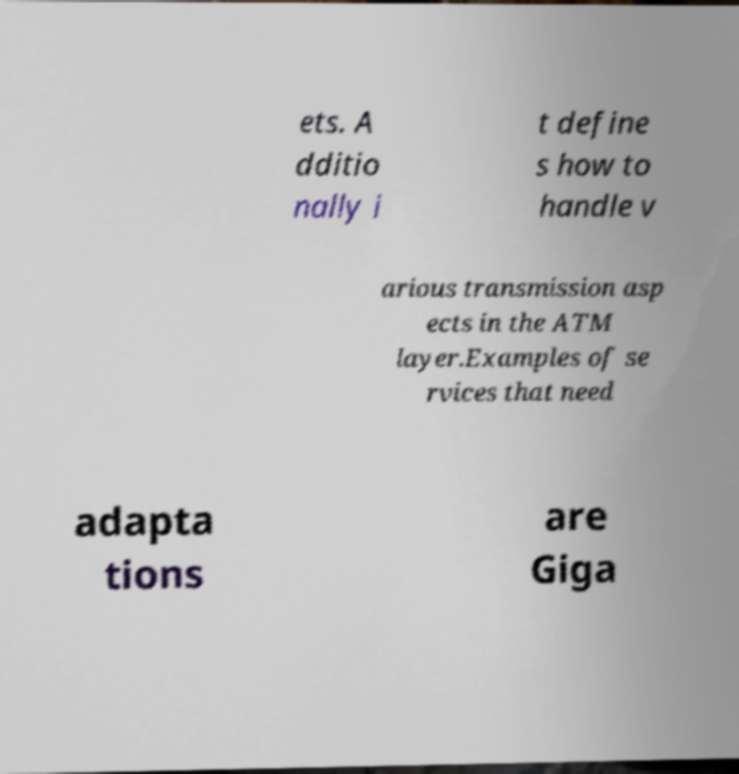What messages or text are displayed in this image? I need them in a readable, typed format. ets. A dditio nally i t define s how to handle v arious transmission asp ects in the ATM layer.Examples of se rvices that need adapta tions are Giga 